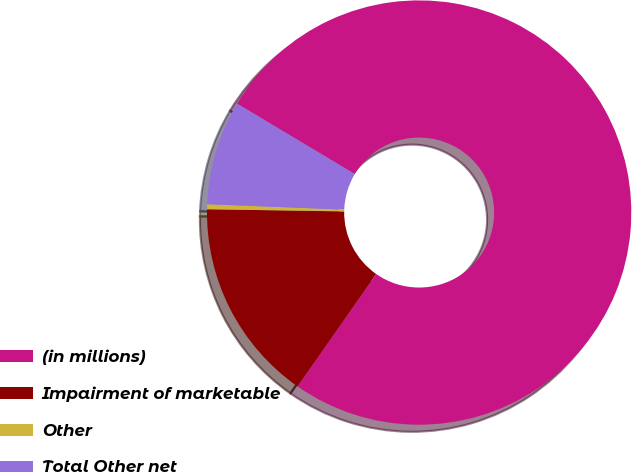Convert chart to OTSL. <chart><loc_0><loc_0><loc_500><loc_500><pie_chart><fcel>(in millions)<fcel>Impairment of marketable<fcel>Other<fcel>Total Other net<nl><fcel>76.14%<fcel>15.53%<fcel>0.38%<fcel>7.95%<nl></chart> 